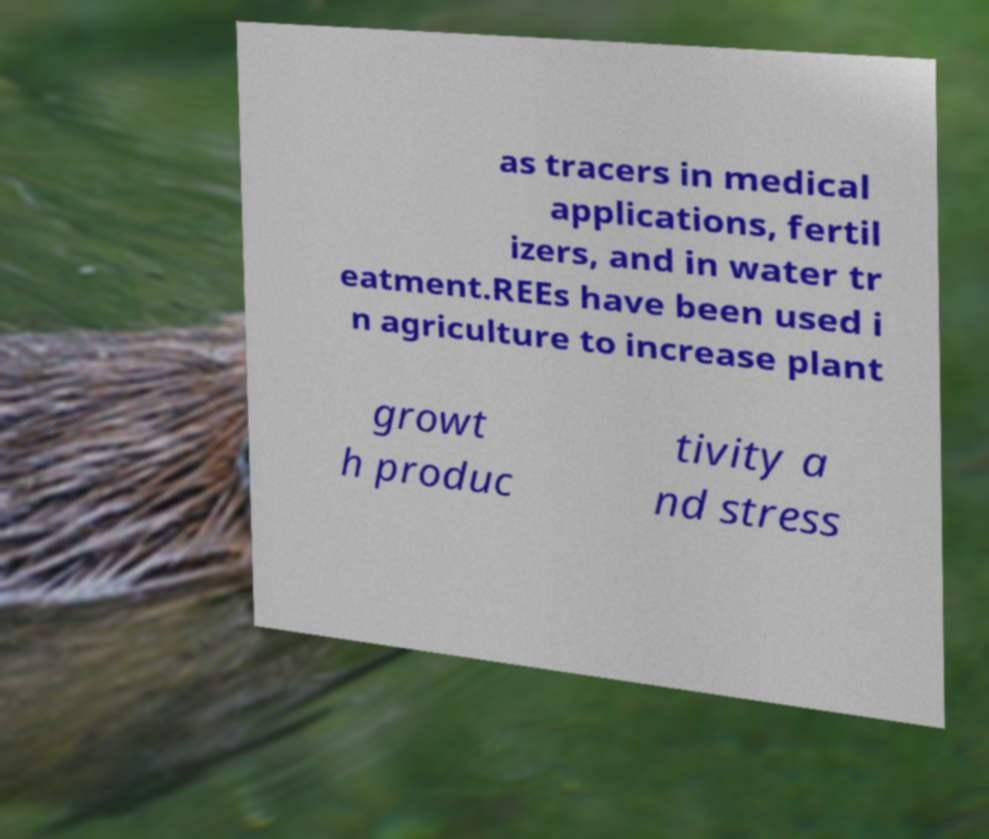There's text embedded in this image that I need extracted. Can you transcribe it verbatim? as tracers in medical applications, fertil izers, and in water tr eatment.REEs have been used i n agriculture to increase plant growt h produc tivity a nd stress 